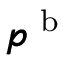<formula> <loc_0><loc_0><loc_500><loc_500>\pm b { p } ^ { b }</formula> 